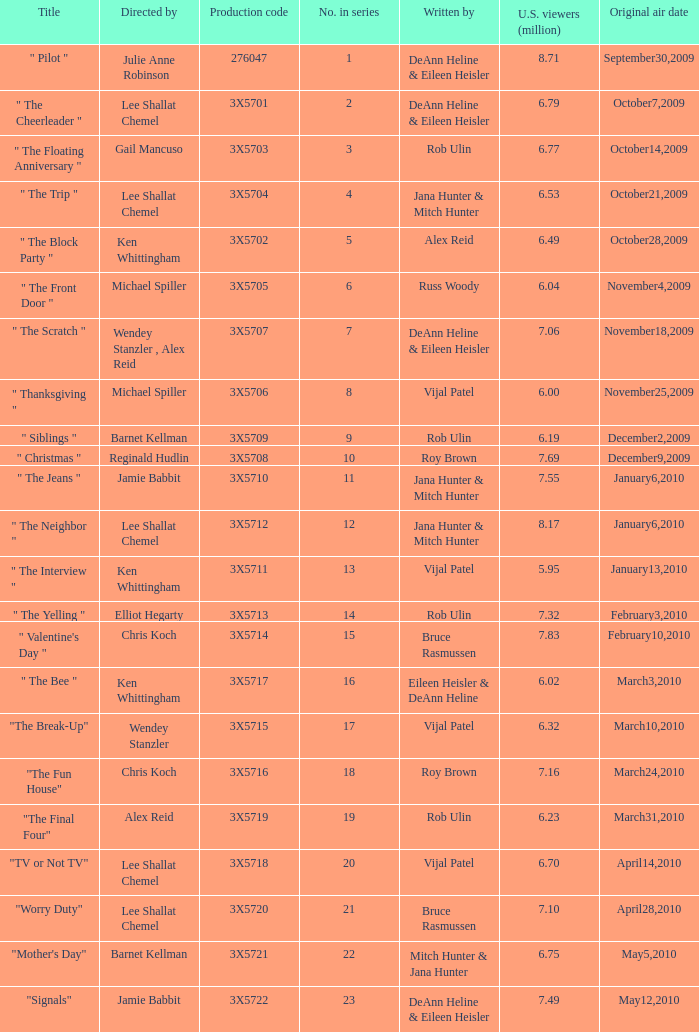Who wrote the episode that got 5.95 million U.S. viewers? Vijal Patel. Could you parse the entire table as a dict? {'header': ['Title', 'Directed by', 'Production code', 'No. in series', 'Written by', 'U.S. viewers (million)', 'Original air date'], 'rows': [['" Pilot "', 'Julie Anne Robinson', '276047', '1', 'DeAnn Heline & Eileen Heisler', '8.71', 'September30,2009'], ['" The Cheerleader "', 'Lee Shallat Chemel', '3X5701', '2', 'DeAnn Heline & Eileen Heisler', '6.79', 'October7,2009'], ['" The Floating Anniversary "', 'Gail Mancuso', '3X5703', '3', 'Rob Ulin', '6.77', 'October14,2009'], ['" The Trip "', 'Lee Shallat Chemel', '3X5704', '4', 'Jana Hunter & Mitch Hunter', '6.53', 'October21,2009'], ['" The Block Party "', 'Ken Whittingham', '3X5702', '5', 'Alex Reid', '6.49', 'October28,2009'], ['" The Front Door "', 'Michael Spiller', '3X5705', '6', 'Russ Woody', '6.04', 'November4,2009'], ['" The Scratch "', 'Wendey Stanzler , Alex Reid', '3X5707', '7', 'DeAnn Heline & Eileen Heisler', '7.06', 'November18,2009'], ['" Thanksgiving "', 'Michael Spiller', '3X5706', '8', 'Vijal Patel', '6.00', 'November25,2009'], ['" Siblings "', 'Barnet Kellman', '3X5709', '9', 'Rob Ulin', '6.19', 'December2,2009'], ['" Christmas "', 'Reginald Hudlin', '3X5708', '10', 'Roy Brown', '7.69', 'December9,2009'], ['" The Jeans "', 'Jamie Babbit', '3X5710', '11', 'Jana Hunter & Mitch Hunter', '7.55', 'January6,2010'], ['" The Neighbor "', 'Lee Shallat Chemel', '3X5712', '12', 'Jana Hunter & Mitch Hunter', '8.17', 'January6,2010'], ['" The Interview "', 'Ken Whittingham', '3X5711', '13', 'Vijal Patel', '5.95', 'January13,2010'], ['" The Yelling "', 'Elliot Hegarty', '3X5713', '14', 'Rob Ulin', '7.32', 'February3,2010'], ['" Valentine\'s Day "', 'Chris Koch', '3X5714', '15', 'Bruce Rasmussen', '7.83', 'February10,2010'], ['" The Bee "', 'Ken Whittingham', '3X5717', '16', 'Eileen Heisler & DeAnn Heline', '6.02', 'March3,2010'], ['"The Break-Up"', 'Wendey Stanzler', '3X5715', '17', 'Vijal Patel', '6.32', 'March10,2010'], ['"The Fun House"', 'Chris Koch', '3X5716', '18', 'Roy Brown', '7.16', 'March24,2010'], ['"The Final Four"', 'Alex Reid', '3X5719', '19', 'Rob Ulin', '6.23', 'March31,2010'], ['"TV or Not TV"', 'Lee Shallat Chemel', '3X5718', '20', 'Vijal Patel', '6.70', 'April14,2010'], ['"Worry Duty"', 'Lee Shallat Chemel', '3X5720', '21', 'Bruce Rasmussen', '7.10', 'April28,2010'], ['"Mother\'s Day"', 'Barnet Kellman', '3X5721', '22', 'Mitch Hunter & Jana Hunter', '6.75', 'May5,2010'], ['"Signals"', 'Jamie Babbit', '3X5722', '23', 'DeAnn Heline & Eileen Heisler', '7.49', 'May12,2010']]} 